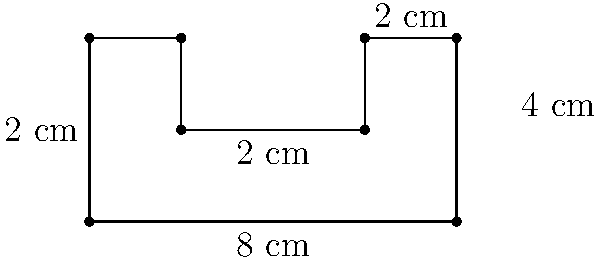As a fellow artist specializing in abstract photography, you've been asked to critique a unique photographic print with an irregular shape. The print has dimensions as shown in the diagram. Calculate the total area of this irregularly shaped print in square centimeters. To calculate the area of this irregularly shaped print, we can break it down into simpler geometric shapes:

1. The print can be divided into a large rectangle and two smaller rectangles.

2. Large rectangle:
   Width = 8 cm
   Height = 2 cm
   Area of large rectangle = $8 \times 2 = 16$ sq cm

3. Left small rectangle:
   Width = 2 cm
   Height = 2 cm
   Area of left small rectangle = $2 \times 2 = 4$ sq cm

4. Right small rectangle:
   Width = 2 cm
   Height = 2 cm
   Area of right small rectangle = $2 \times 2 = 4$ sq cm

5. Total area:
   $$\text{Total Area} = \text{Area of large rectangle} + \text{Area of left small rectangle} + \text{Area of right small rectangle}$$
   $$\text{Total Area} = 16 + 4 + 4 = 24 \text{ sq cm}$$

Therefore, the total area of the irregularly shaped photographic print is 24 square centimeters.
Answer: 24 sq cm 